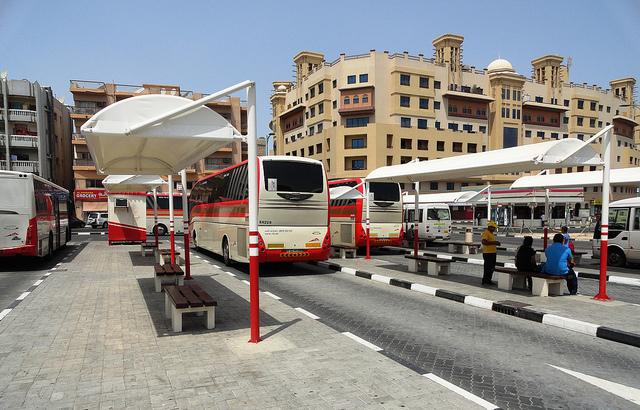What are the people waiting for?
Keep it brief. Bus. Is this place a train station?
Quick response, please. No. Where are the people?
Answer briefly. Bench. 